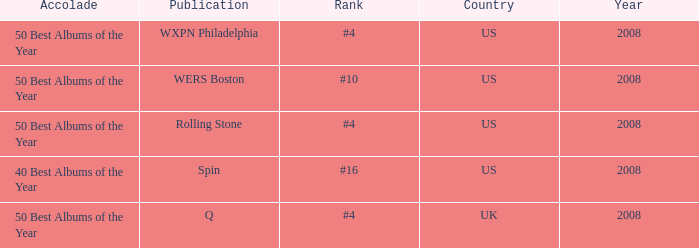Which rank's country is the US when the accolade is 40 best albums of the year? #16. 